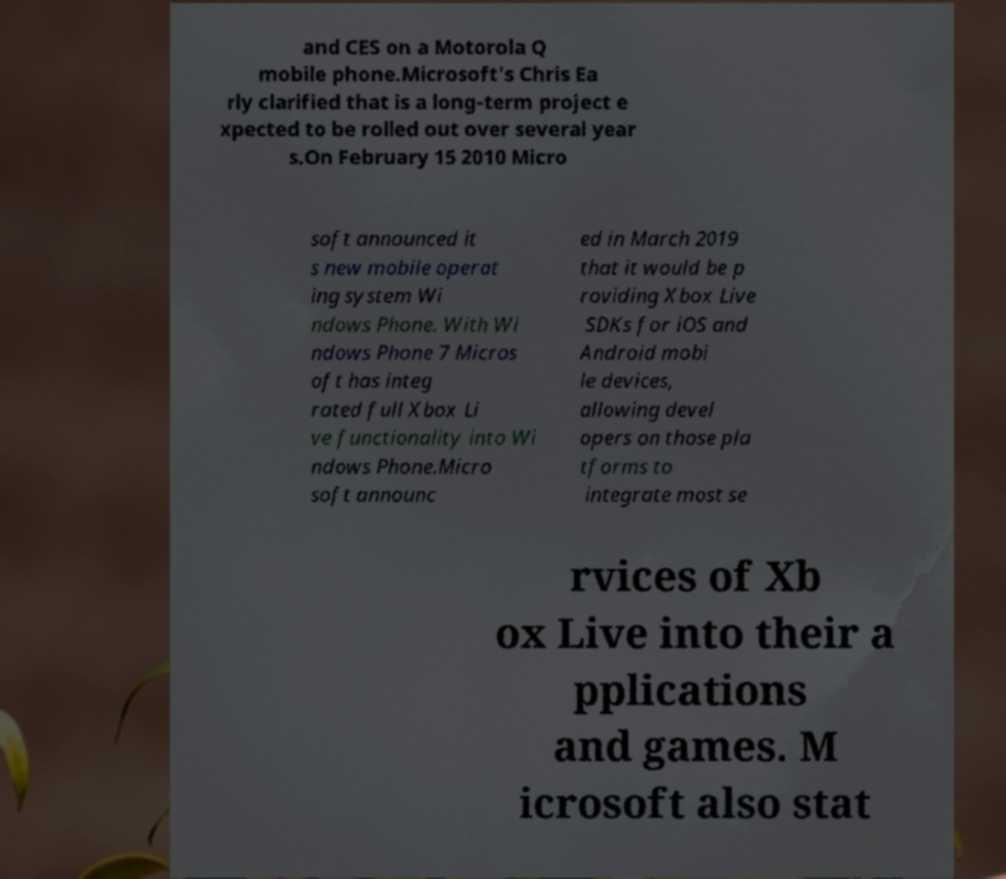There's text embedded in this image that I need extracted. Can you transcribe it verbatim? and CES on a Motorola Q mobile phone.Microsoft's Chris Ea rly clarified that is a long-term project e xpected to be rolled out over several year s.On February 15 2010 Micro soft announced it s new mobile operat ing system Wi ndows Phone. With Wi ndows Phone 7 Micros oft has integ rated full Xbox Li ve functionality into Wi ndows Phone.Micro soft announc ed in March 2019 that it would be p roviding Xbox Live SDKs for iOS and Android mobi le devices, allowing devel opers on those pla tforms to integrate most se rvices of Xb ox Live into their a pplications and games. M icrosoft also stat 